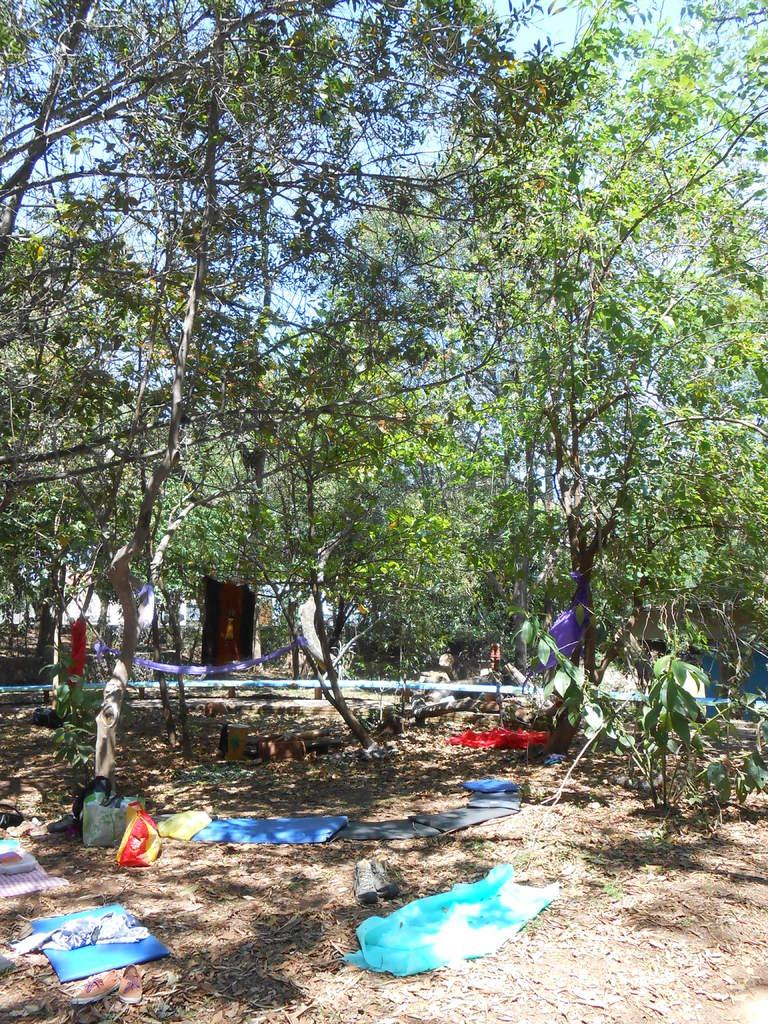What type of vegetation can be seen in the image? There are trees and plants in the image. What else is present on the ground in the image? Clothes and carry bags are on the ground. What is the condition of the ground in the image? Dried leaves are visible in the image. How would you describe the sky in the image? The sky is blue and cloudy. What type of pizzas are being served by the government in the image? There are no pizzas or any reference to the government present in the image. What role does the spoon play in the image? There is no spoon present in the image. 